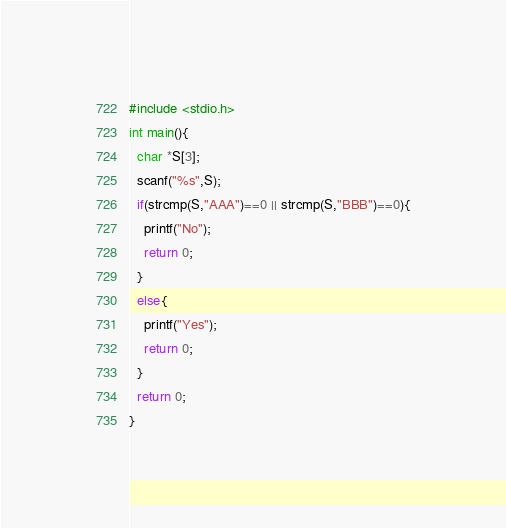<code> <loc_0><loc_0><loc_500><loc_500><_C_>#include <stdio.h>
int main(){
  char *S[3];
  scanf("%s",S);
  if(strcmp(S,"AAA")==0 || strcmp(S,"BBB")==0){
    printf("No");
    return 0;
  }
  else{
    printf("Yes");
    return 0;
  }
  return 0;
}</code> 